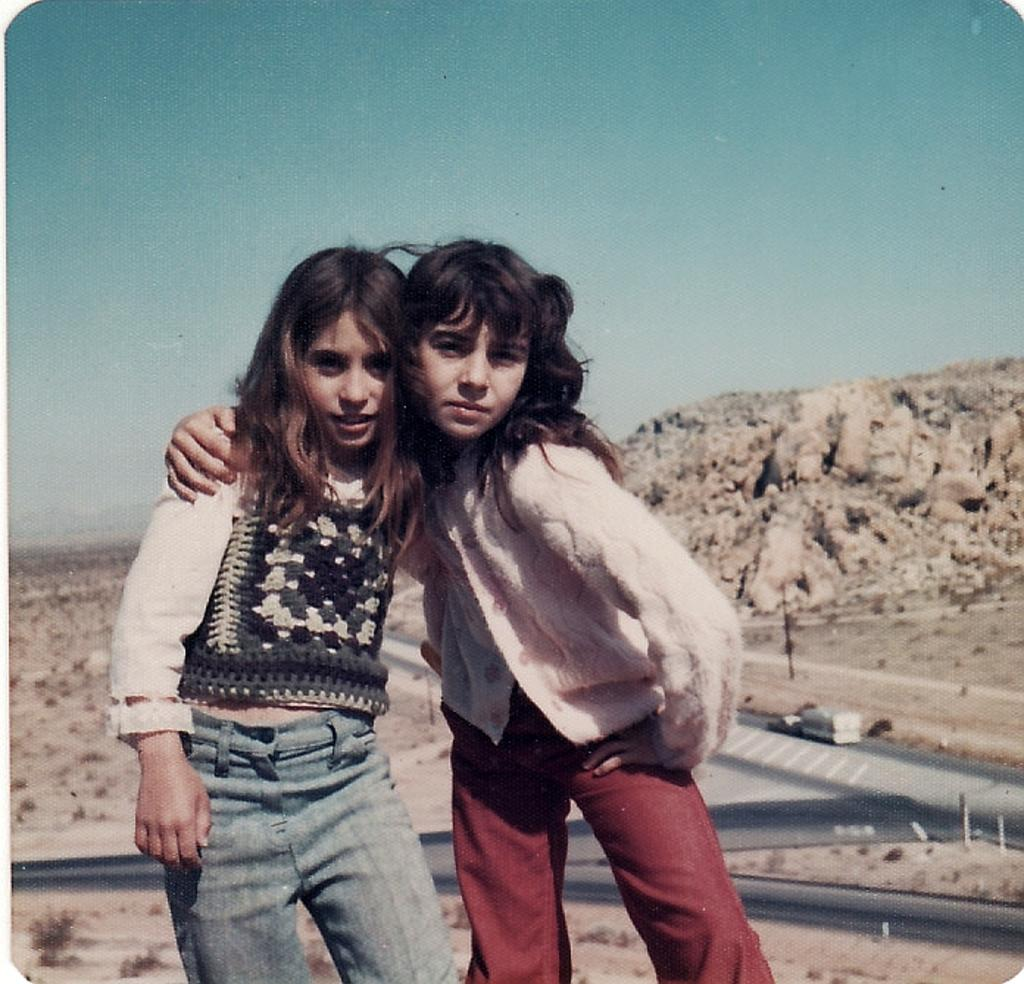How many children are present in the image? There are two children standing in the image. What can be seen in the background of the image? There is a vehicle on the road, hills, plants, and the sky visible in the background of the image. What is the condition of the sky in the image? The sky appears cloudy in the image. How many women are holding baby snakes in the image? There are no women or snakes present in the image. 